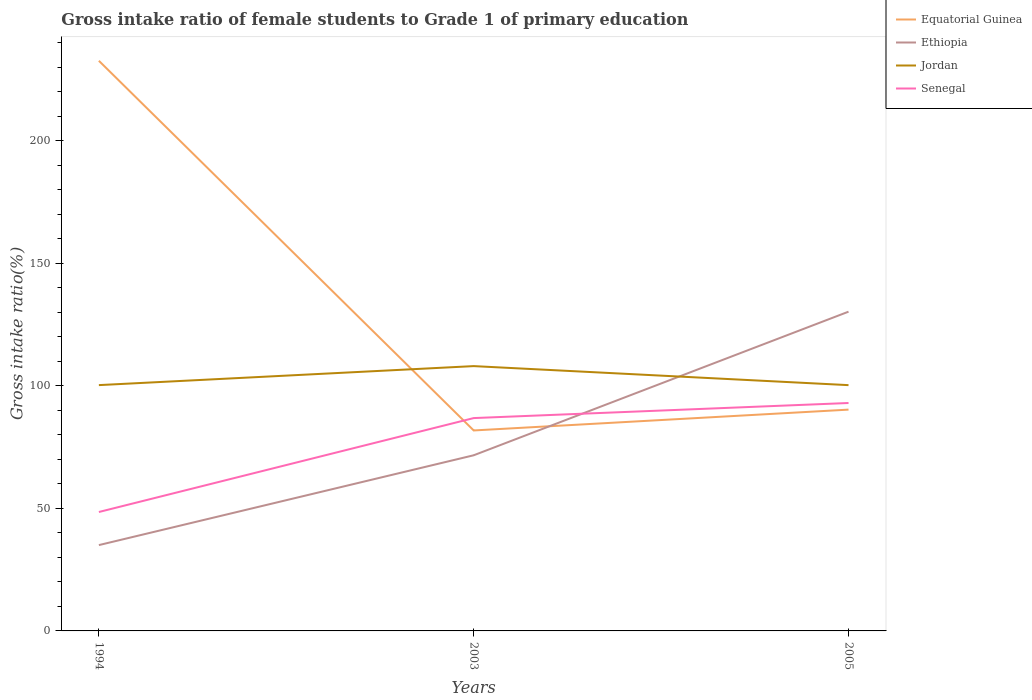Across all years, what is the maximum gross intake ratio in Jordan?
Make the answer very short. 100.27. What is the total gross intake ratio in Jordan in the graph?
Give a very brief answer. 0.02. What is the difference between the highest and the second highest gross intake ratio in Senegal?
Provide a succinct answer. 44.47. How many lines are there?
Offer a very short reply. 4. What is the difference between two consecutive major ticks on the Y-axis?
Your answer should be compact. 50. Does the graph contain grids?
Give a very brief answer. No. How are the legend labels stacked?
Provide a short and direct response. Vertical. What is the title of the graph?
Make the answer very short. Gross intake ratio of female students to Grade 1 of primary education. Does "South Africa" appear as one of the legend labels in the graph?
Offer a very short reply. No. What is the label or title of the X-axis?
Keep it short and to the point. Years. What is the label or title of the Y-axis?
Your answer should be very brief. Gross intake ratio(%). What is the Gross intake ratio(%) in Equatorial Guinea in 1994?
Ensure brevity in your answer.  232.59. What is the Gross intake ratio(%) of Ethiopia in 1994?
Your answer should be compact. 35.01. What is the Gross intake ratio(%) in Jordan in 1994?
Keep it short and to the point. 100.28. What is the Gross intake ratio(%) in Senegal in 1994?
Offer a terse response. 48.52. What is the Gross intake ratio(%) of Equatorial Guinea in 2003?
Provide a succinct answer. 81.78. What is the Gross intake ratio(%) in Ethiopia in 2003?
Your response must be concise. 71.66. What is the Gross intake ratio(%) of Jordan in 2003?
Your answer should be very brief. 108.03. What is the Gross intake ratio(%) in Senegal in 2003?
Your response must be concise. 86.83. What is the Gross intake ratio(%) of Equatorial Guinea in 2005?
Your answer should be very brief. 90.28. What is the Gross intake ratio(%) of Ethiopia in 2005?
Your answer should be compact. 130.24. What is the Gross intake ratio(%) in Jordan in 2005?
Your response must be concise. 100.27. What is the Gross intake ratio(%) in Senegal in 2005?
Offer a very short reply. 92.98. Across all years, what is the maximum Gross intake ratio(%) in Equatorial Guinea?
Your answer should be very brief. 232.59. Across all years, what is the maximum Gross intake ratio(%) in Ethiopia?
Offer a very short reply. 130.24. Across all years, what is the maximum Gross intake ratio(%) in Jordan?
Provide a succinct answer. 108.03. Across all years, what is the maximum Gross intake ratio(%) in Senegal?
Your answer should be very brief. 92.98. Across all years, what is the minimum Gross intake ratio(%) in Equatorial Guinea?
Your answer should be compact. 81.78. Across all years, what is the minimum Gross intake ratio(%) in Ethiopia?
Make the answer very short. 35.01. Across all years, what is the minimum Gross intake ratio(%) of Jordan?
Offer a very short reply. 100.27. Across all years, what is the minimum Gross intake ratio(%) of Senegal?
Make the answer very short. 48.52. What is the total Gross intake ratio(%) of Equatorial Guinea in the graph?
Give a very brief answer. 404.65. What is the total Gross intake ratio(%) of Ethiopia in the graph?
Your response must be concise. 236.91. What is the total Gross intake ratio(%) in Jordan in the graph?
Provide a short and direct response. 308.58. What is the total Gross intake ratio(%) of Senegal in the graph?
Your answer should be very brief. 228.33. What is the difference between the Gross intake ratio(%) of Equatorial Guinea in 1994 and that in 2003?
Ensure brevity in your answer.  150.81. What is the difference between the Gross intake ratio(%) in Ethiopia in 1994 and that in 2003?
Offer a terse response. -36.64. What is the difference between the Gross intake ratio(%) in Jordan in 1994 and that in 2003?
Your answer should be compact. -7.75. What is the difference between the Gross intake ratio(%) in Senegal in 1994 and that in 2003?
Keep it short and to the point. -38.32. What is the difference between the Gross intake ratio(%) in Equatorial Guinea in 1994 and that in 2005?
Your answer should be very brief. 142.31. What is the difference between the Gross intake ratio(%) in Ethiopia in 1994 and that in 2005?
Provide a succinct answer. -95.22. What is the difference between the Gross intake ratio(%) in Jordan in 1994 and that in 2005?
Provide a short and direct response. 0.01. What is the difference between the Gross intake ratio(%) in Senegal in 1994 and that in 2005?
Keep it short and to the point. -44.47. What is the difference between the Gross intake ratio(%) in Equatorial Guinea in 2003 and that in 2005?
Provide a short and direct response. -8.5. What is the difference between the Gross intake ratio(%) in Ethiopia in 2003 and that in 2005?
Offer a terse response. -58.58. What is the difference between the Gross intake ratio(%) in Jordan in 2003 and that in 2005?
Offer a very short reply. 7.76. What is the difference between the Gross intake ratio(%) in Senegal in 2003 and that in 2005?
Offer a terse response. -6.15. What is the difference between the Gross intake ratio(%) in Equatorial Guinea in 1994 and the Gross intake ratio(%) in Ethiopia in 2003?
Offer a very short reply. 160.93. What is the difference between the Gross intake ratio(%) of Equatorial Guinea in 1994 and the Gross intake ratio(%) of Jordan in 2003?
Make the answer very short. 124.56. What is the difference between the Gross intake ratio(%) of Equatorial Guinea in 1994 and the Gross intake ratio(%) of Senegal in 2003?
Your answer should be very brief. 145.76. What is the difference between the Gross intake ratio(%) in Ethiopia in 1994 and the Gross intake ratio(%) in Jordan in 2003?
Your response must be concise. -73.02. What is the difference between the Gross intake ratio(%) of Ethiopia in 1994 and the Gross intake ratio(%) of Senegal in 2003?
Keep it short and to the point. -51.82. What is the difference between the Gross intake ratio(%) of Jordan in 1994 and the Gross intake ratio(%) of Senegal in 2003?
Your answer should be compact. 13.45. What is the difference between the Gross intake ratio(%) of Equatorial Guinea in 1994 and the Gross intake ratio(%) of Ethiopia in 2005?
Your answer should be compact. 102.35. What is the difference between the Gross intake ratio(%) of Equatorial Guinea in 1994 and the Gross intake ratio(%) of Jordan in 2005?
Offer a very short reply. 132.32. What is the difference between the Gross intake ratio(%) of Equatorial Guinea in 1994 and the Gross intake ratio(%) of Senegal in 2005?
Keep it short and to the point. 139.61. What is the difference between the Gross intake ratio(%) of Ethiopia in 1994 and the Gross intake ratio(%) of Jordan in 2005?
Your response must be concise. -65.26. What is the difference between the Gross intake ratio(%) of Ethiopia in 1994 and the Gross intake ratio(%) of Senegal in 2005?
Offer a terse response. -57.97. What is the difference between the Gross intake ratio(%) of Jordan in 1994 and the Gross intake ratio(%) of Senegal in 2005?
Make the answer very short. 7.3. What is the difference between the Gross intake ratio(%) in Equatorial Guinea in 2003 and the Gross intake ratio(%) in Ethiopia in 2005?
Provide a succinct answer. -48.45. What is the difference between the Gross intake ratio(%) in Equatorial Guinea in 2003 and the Gross intake ratio(%) in Jordan in 2005?
Offer a very short reply. -18.49. What is the difference between the Gross intake ratio(%) in Equatorial Guinea in 2003 and the Gross intake ratio(%) in Senegal in 2005?
Provide a short and direct response. -11.2. What is the difference between the Gross intake ratio(%) of Ethiopia in 2003 and the Gross intake ratio(%) of Jordan in 2005?
Give a very brief answer. -28.61. What is the difference between the Gross intake ratio(%) in Ethiopia in 2003 and the Gross intake ratio(%) in Senegal in 2005?
Provide a short and direct response. -21.33. What is the difference between the Gross intake ratio(%) of Jordan in 2003 and the Gross intake ratio(%) of Senegal in 2005?
Offer a terse response. 15.05. What is the average Gross intake ratio(%) in Equatorial Guinea per year?
Your answer should be compact. 134.88. What is the average Gross intake ratio(%) in Ethiopia per year?
Ensure brevity in your answer.  78.97. What is the average Gross intake ratio(%) in Jordan per year?
Keep it short and to the point. 102.86. What is the average Gross intake ratio(%) in Senegal per year?
Your answer should be compact. 76.11. In the year 1994, what is the difference between the Gross intake ratio(%) in Equatorial Guinea and Gross intake ratio(%) in Ethiopia?
Give a very brief answer. 197.58. In the year 1994, what is the difference between the Gross intake ratio(%) of Equatorial Guinea and Gross intake ratio(%) of Jordan?
Provide a short and direct response. 132.31. In the year 1994, what is the difference between the Gross intake ratio(%) of Equatorial Guinea and Gross intake ratio(%) of Senegal?
Offer a very short reply. 184.07. In the year 1994, what is the difference between the Gross intake ratio(%) in Ethiopia and Gross intake ratio(%) in Jordan?
Ensure brevity in your answer.  -65.27. In the year 1994, what is the difference between the Gross intake ratio(%) in Ethiopia and Gross intake ratio(%) in Senegal?
Keep it short and to the point. -13.5. In the year 1994, what is the difference between the Gross intake ratio(%) in Jordan and Gross intake ratio(%) in Senegal?
Your answer should be very brief. 51.77. In the year 2003, what is the difference between the Gross intake ratio(%) of Equatorial Guinea and Gross intake ratio(%) of Ethiopia?
Offer a terse response. 10.13. In the year 2003, what is the difference between the Gross intake ratio(%) of Equatorial Guinea and Gross intake ratio(%) of Jordan?
Ensure brevity in your answer.  -26.25. In the year 2003, what is the difference between the Gross intake ratio(%) of Equatorial Guinea and Gross intake ratio(%) of Senegal?
Ensure brevity in your answer.  -5.05. In the year 2003, what is the difference between the Gross intake ratio(%) in Ethiopia and Gross intake ratio(%) in Jordan?
Make the answer very short. -36.38. In the year 2003, what is the difference between the Gross intake ratio(%) of Ethiopia and Gross intake ratio(%) of Senegal?
Provide a succinct answer. -15.18. In the year 2003, what is the difference between the Gross intake ratio(%) of Jordan and Gross intake ratio(%) of Senegal?
Give a very brief answer. 21.2. In the year 2005, what is the difference between the Gross intake ratio(%) in Equatorial Guinea and Gross intake ratio(%) in Ethiopia?
Your answer should be compact. -39.96. In the year 2005, what is the difference between the Gross intake ratio(%) in Equatorial Guinea and Gross intake ratio(%) in Jordan?
Ensure brevity in your answer.  -9.99. In the year 2005, what is the difference between the Gross intake ratio(%) of Equatorial Guinea and Gross intake ratio(%) of Senegal?
Provide a succinct answer. -2.7. In the year 2005, what is the difference between the Gross intake ratio(%) in Ethiopia and Gross intake ratio(%) in Jordan?
Provide a short and direct response. 29.97. In the year 2005, what is the difference between the Gross intake ratio(%) of Ethiopia and Gross intake ratio(%) of Senegal?
Make the answer very short. 37.25. In the year 2005, what is the difference between the Gross intake ratio(%) in Jordan and Gross intake ratio(%) in Senegal?
Ensure brevity in your answer.  7.29. What is the ratio of the Gross intake ratio(%) in Equatorial Guinea in 1994 to that in 2003?
Ensure brevity in your answer.  2.84. What is the ratio of the Gross intake ratio(%) of Ethiopia in 1994 to that in 2003?
Your answer should be compact. 0.49. What is the ratio of the Gross intake ratio(%) in Jordan in 1994 to that in 2003?
Keep it short and to the point. 0.93. What is the ratio of the Gross intake ratio(%) in Senegal in 1994 to that in 2003?
Give a very brief answer. 0.56. What is the ratio of the Gross intake ratio(%) of Equatorial Guinea in 1994 to that in 2005?
Your answer should be very brief. 2.58. What is the ratio of the Gross intake ratio(%) in Ethiopia in 1994 to that in 2005?
Your answer should be compact. 0.27. What is the ratio of the Gross intake ratio(%) in Jordan in 1994 to that in 2005?
Your response must be concise. 1. What is the ratio of the Gross intake ratio(%) in Senegal in 1994 to that in 2005?
Offer a very short reply. 0.52. What is the ratio of the Gross intake ratio(%) in Equatorial Guinea in 2003 to that in 2005?
Your answer should be very brief. 0.91. What is the ratio of the Gross intake ratio(%) of Ethiopia in 2003 to that in 2005?
Keep it short and to the point. 0.55. What is the ratio of the Gross intake ratio(%) in Jordan in 2003 to that in 2005?
Your response must be concise. 1.08. What is the ratio of the Gross intake ratio(%) of Senegal in 2003 to that in 2005?
Offer a terse response. 0.93. What is the difference between the highest and the second highest Gross intake ratio(%) of Equatorial Guinea?
Offer a very short reply. 142.31. What is the difference between the highest and the second highest Gross intake ratio(%) in Ethiopia?
Offer a terse response. 58.58. What is the difference between the highest and the second highest Gross intake ratio(%) of Jordan?
Make the answer very short. 7.75. What is the difference between the highest and the second highest Gross intake ratio(%) of Senegal?
Make the answer very short. 6.15. What is the difference between the highest and the lowest Gross intake ratio(%) in Equatorial Guinea?
Ensure brevity in your answer.  150.81. What is the difference between the highest and the lowest Gross intake ratio(%) of Ethiopia?
Your answer should be compact. 95.22. What is the difference between the highest and the lowest Gross intake ratio(%) of Jordan?
Your answer should be very brief. 7.76. What is the difference between the highest and the lowest Gross intake ratio(%) in Senegal?
Give a very brief answer. 44.47. 